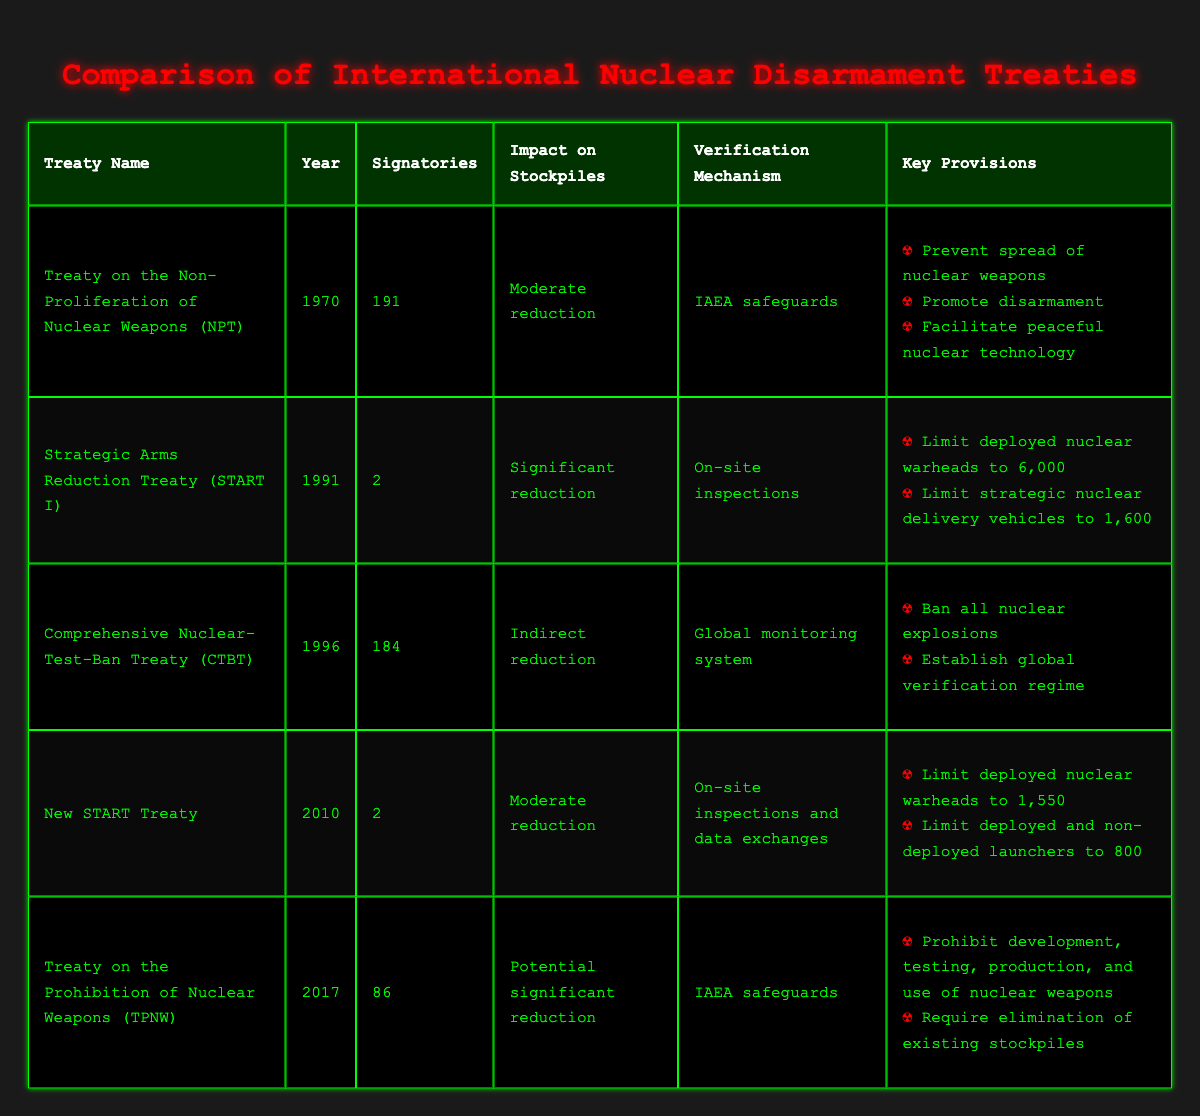What year was the Treaty on the Non-Proliferation of Nuclear Weapons (NPT) established? The table lists the year of establishment for each treaty. For the NPT, the corresponding year is clearly stated as 1970.
Answer: 1970 How many signatories does the Strategic Arms Reduction Treaty (START I) have? The table explicitly mentions that START I has 2 signatories.
Answer: 2 Which treaty has the verification mechanism of "Global monitoring system"? By examining the verification mechanism column in the table, it is clear that the Comprehensive Nuclear-Test-Ban Treaty (CTBT) has the verification mechanism of "Global monitoring system".
Answer: Comprehensive Nuclear-Test-Ban Treaty (CTBT) What is the impact on stockpiles of the Treaty on the Prohibition of Nuclear Weapons (TPNW)? The table states that the impact on stockpiles of the TPNW is a "Potential significant reduction".
Answer: Potential significant reduction Which treaty has the most signatories? To find the treaty with the most signatories, one must compare the signatory numbers across all rows. The NPT has the highest at 191 signatories.
Answer: Treaty on the Non-Proliferation of Nuclear Weapons (NPT) If we sum the number of signatories from the New START Treaty and TPNW, what would it equal? New START Treaty has 2 signatories and TPNW has 86 signatories. Summing 2 + 86 equals 88.
Answer: 88 Is it true that the NPT promotes disarmament? Looking at the key provisions for NPT in the table, one of the provisions specifically states that it aims to "Promote disarmament", confirming the statement is true.
Answer: Yes Which treaty was established most recently, and what is its impact on stockpiles? The data shows the establishment years, indicating TPNW starting in 2017 is the most recent. Its impact on stockpiles is documented as "Potential significant reduction".
Answer: Treaty on the Prohibition of Nuclear Weapons (TPNW); Potential significant reduction What verification mechanism does the New START Treaty utilize? The table specifies that the New START Treaty uses "On-site inspections and data exchanges" as its verification mechanism.
Answer: On-site inspections and data exchanges 